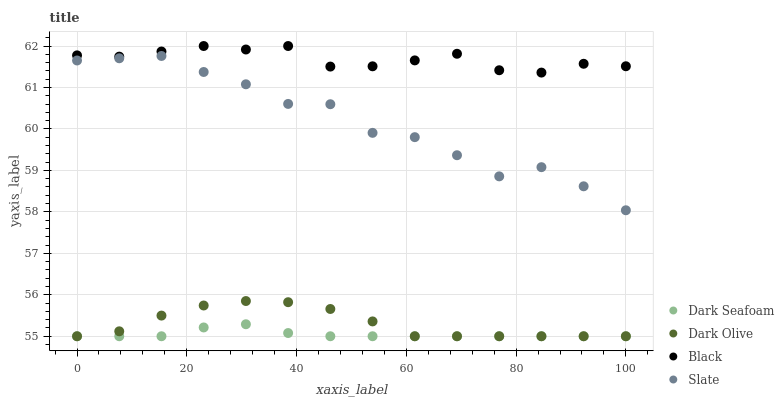Does Dark Seafoam have the minimum area under the curve?
Answer yes or no. Yes. Does Black have the maximum area under the curve?
Answer yes or no. Yes. Does Dark Olive have the minimum area under the curve?
Answer yes or no. No. Does Dark Olive have the maximum area under the curve?
Answer yes or no. No. Is Dark Seafoam the smoothest?
Answer yes or no. Yes. Is Slate the roughest?
Answer yes or no. Yes. Is Dark Olive the smoothest?
Answer yes or no. No. Is Dark Olive the roughest?
Answer yes or no. No. Does Dark Seafoam have the lowest value?
Answer yes or no. Yes. Does Black have the lowest value?
Answer yes or no. No. Does Black have the highest value?
Answer yes or no. Yes. Does Dark Olive have the highest value?
Answer yes or no. No. Is Dark Seafoam less than Slate?
Answer yes or no. Yes. Is Black greater than Dark Olive?
Answer yes or no. Yes. Does Dark Olive intersect Dark Seafoam?
Answer yes or no. Yes. Is Dark Olive less than Dark Seafoam?
Answer yes or no. No. Is Dark Olive greater than Dark Seafoam?
Answer yes or no. No. Does Dark Seafoam intersect Slate?
Answer yes or no. No. 